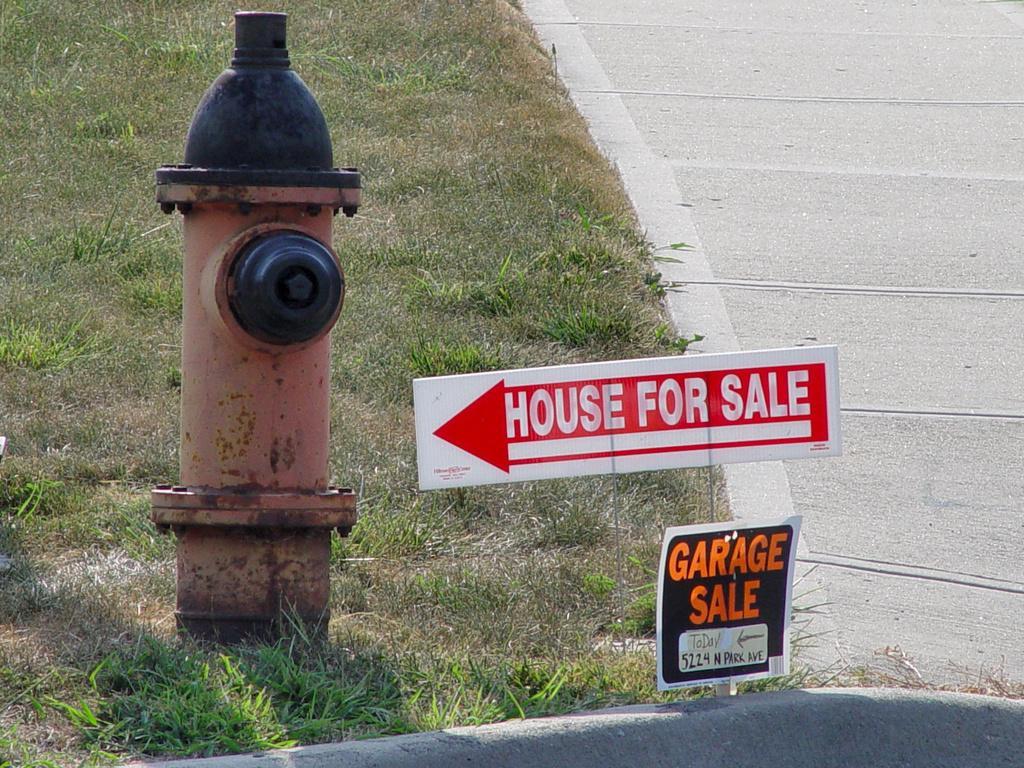Describe this image in one or two sentences. In the picture I can see a fire hydrant, grass and boards. On these words I can see something written on them. 